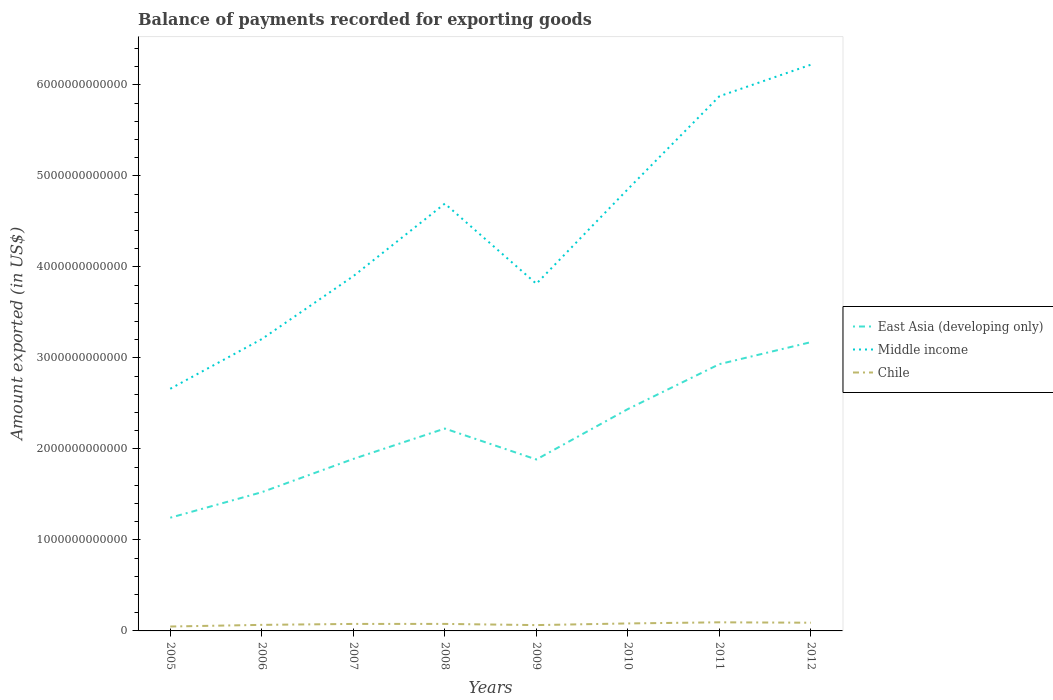How many different coloured lines are there?
Keep it short and to the point. 3. Does the line corresponding to Middle income intersect with the line corresponding to Chile?
Give a very brief answer. No. Is the number of lines equal to the number of legend labels?
Keep it short and to the point. Yes. Across all years, what is the maximum amount exported in East Asia (developing only)?
Give a very brief answer. 1.24e+12. In which year was the amount exported in Chile maximum?
Your answer should be compact. 2005. What is the total amount exported in Middle income in the graph?
Your answer should be very brief. -3.21e+12. What is the difference between the highest and the second highest amount exported in Chile?
Your answer should be very brief. 4.61e+1. What is the difference between two consecutive major ticks on the Y-axis?
Your answer should be very brief. 1.00e+12. Does the graph contain any zero values?
Offer a terse response. No. Where does the legend appear in the graph?
Offer a terse response. Center right. What is the title of the graph?
Provide a succinct answer. Balance of payments recorded for exporting goods. Does "Switzerland" appear as one of the legend labels in the graph?
Make the answer very short. No. What is the label or title of the Y-axis?
Provide a succinct answer. Amount exported (in US$). What is the Amount exported (in US$) in East Asia (developing only) in 2005?
Make the answer very short. 1.24e+12. What is the Amount exported (in US$) of Middle income in 2005?
Offer a terse response. 2.66e+12. What is the Amount exported (in US$) in Chile in 2005?
Your answer should be compact. 4.84e+1. What is the Amount exported (in US$) in East Asia (developing only) in 2006?
Your answer should be compact. 1.52e+12. What is the Amount exported (in US$) of Middle income in 2006?
Ensure brevity in your answer.  3.21e+12. What is the Amount exported (in US$) in Chile in 2006?
Your answer should be compact. 6.65e+1. What is the Amount exported (in US$) of East Asia (developing only) in 2007?
Keep it short and to the point. 1.89e+12. What is the Amount exported (in US$) in Middle income in 2007?
Make the answer very short. 3.90e+12. What is the Amount exported (in US$) of Chile in 2007?
Your answer should be very brief. 7.69e+1. What is the Amount exported (in US$) of East Asia (developing only) in 2008?
Your answer should be compact. 2.22e+12. What is the Amount exported (in US$) of Middle income in 2008?
Offer a very short reply. 4.70e+12. What is the Amount exported (in US$) in Chile in 2008?
Give a very brief answer. 7.71e+1. What is the Amount exported (in US$) in East Asia (developing only) in 2009?
Your response must be concise. 1.88e+12. What is the Amount exported (in US$) of Middle income in 2009?
Offer a terse response. 3.81e+12. What is the Amount exported (in US$) in Chile in 2009?
Make the answer very short. 6.40e+1. What is the Amount exported (in US$) of East Asia (developing only) in 2010?
Your answer should be compact. 2.44e+12. What is the Amount exported (in US$) of Middle income in 2010?
Ensure brevity in your answer.  4.85e+12. What is the Amount exported (in US$) in Chile in 2010?
Give a very brief answer. 8.23e+1. What is the Amount exported (in US$) in East Asia (developing only) in 2011?
Make the answer very short. 2.93e+12. What is the Amount exported (in US$) of Middle income in 2011?
Provide a succinct answer. 5.87e+12. What is the Amount exported (in US$) in Chile in 2011?
Offer a terse response. 9.45e+1. What is the Amount exported (in US$) in East Asia (developing only) in 2012?
Your response must be concise. 3.17e+12. What is the Amount exported (in US$) of Middle income in 2012?
Provide a succinct answer. 6.22e+12. What is the Amount exported (in US$) of Chile in 2012?
Your response must be concise. 9.02e+1. Across all years, what is the maximum Amount exported (in US$) in East Asia (developing only)?
Provide a succinct answer. 3.17e+12. Across all years, what is the maximum Amount exported (in US$) of Middle income?
Offer a very short reply. 6.22e+12. Across all years, what is the maximum Amount exported (in US$) of Chile?
Make the answer very short. 9.45e+1. Across all years, what is the minimum Amount exported (in US$) of East Asia (developing only)?
Your answer should be very brief. 1.24e+12. Across all years, what is the minimum Amount exported (in US$) in Middle income?
Your answer should be very brief. 2.66e+12. Across all years, what is the minimum Amount exported (in US$) of Chile?
Provide a short and direct response. 4.84e+1. What is the total Amount exported (in US$) of East Asia (developing only) in the graph?
Offer a very short reply. 1.73e+13. What is the total Amount exported (in US$) in Middle income in the graph?
Provide a short and direct response. 3.52e+13. What is the total Amount exported (in US$) in Chile in the graph?
Your answer should be very brief. 6.00e+11. What is the difference between the Amount exported (in US$) in East Asia (developing only) in 2005 and that in 2006?
Keep it short and to the point. -2.80e+11. What is the difference between the Amount exported (in US$) in Middle income in 2005 and that in 2006?
Provide a short and direct response. -5.46e+11. What is the difference between the Amount exported (in US$) in Chile in 2005 and that in 2006?
Keep it short and to the point. -1.81e+1. What is the difference between the Amount exported (in US$) in East Asia (developing only) in 2005 and that in 2007?
Your answer should be compact. -6.46e+11. What is the difference between the Amount exported (in US$) of Middle income in 2005 and that in 2007?
Provide a short and direct response. -1.24e+12. What is the difference between the Amount exported (in US$) in Chile in 2005 and that in 2007?
Provide a succinct answer. -2.85e+1. What is the difference between the Amount exported (in US$) of East Asia (developing only) in 2005 and that in 2008?
Your answer should be compact. -9.80e+11. What is the difference between the Amount exported (in US$) of Middle income in 2005 and that in 2008?
Ensure brevity in your answer.  -2.03e+12. What is the difference between the Amount exported (in US$) of Chile in 2005 and that in 2008?
Your answer should be compact. -2.87e+1. What is the difference between the Amount exported (in US$) of East Asia (developing only) in 2005 and that in 2009?
Keep it short and to the point. -6.40e+11. What is the difference between the Amount exported (in US$) of Middle income in 2005 and that in 2009?
Give a very brief answer. -1.15e+12. What is the difference between the Amount exported (in US$) of Chile in 2005 and that in 2009?
Ensure brevity in your answer.  -1.56e+1. What is the difference between the Amount exported (in US$) of East Asia (developing only) in 2005 and that in 2010?
Your response must be concise. -1.19e+12. What is the difference between the Amount exported (in US$) of Middle income in 2005 and that in 2010?
Your answer should be very brief. -2.19e+12. What is the difference between the Amount exported (in US$) of Chile in 2005 and that in 2010?
Your response must be concise. -3.39e+1. What is the difference between the Amount exported (in US$) in East Asia (developing only) in 2005 and that in 2011?
Provide a short and direct response. -1.69e+12. What is the difference between the Amount exported (in US$) in Middle income in 2005 and that in 2011?
Provide a succinct answer. -3.21e+12. What is the difference between the Amount exported (in US$) in Chile in 2005 and that in 2011?
Ensure brevity in your answer.  -4.61e+1. What is the difference between the Amount exported (in US$) of East Asia (developing only) in 2005 and that in 2012?
Keep it short and to the point. -1.93e+12. What is the difference between the Amount exported (in US$) of Middle income in 2005 and that in 2012?
Offer a very short reply. -3.56e+12. What is the difference between the Amount exported (in US$) in Chile in 2005 and that in 2012?
Your answer should be very brief. -4.18e+1. What is the difference between the Amount exported (in US$) in East Asia (developing only) in 2006 and that in 2007?
Ensure brevity in your answer.  -3.66e+11. What is the difference between the Amount exported (in US$) of Middle income in 2006 and that in 2007?
Provide a short and direct response. -6.91e+11. What is the difference between the Amount exported (in US$) in Chile in 2006 and that in 2007?
Your answer should be very brief. -1.04e+1. What is the difference between the Amount exported (in US$) of East Asia (developing only) in 2006 and that in 2008?
Make the answer very short. -6.99e+11. What is the difference between the Amount exported (in US$) of Middle income in 2006 and that in 2008?
Give a very brief answer. -1.49e+12. What is the difference between the Amount exported (in US$) in Chile in 2006 and that in 2008?
Give a very brief answer. -1.06e+1. What is the difference between the Amount exported (in US$) in East Asia (developing only) in 2006 and that in 2009?
Ensure brevity in your answer.  -3.59e+11. What is the difference between the Amount exported (in US$) of Middle income in 2006 and that in 2009?
Your response must be concise. -6.08e+11. What is the difference between the Amount exported (in US$) of Chile in 2006 and that in 2009?
Keep it short and to the point. 2.56e+09. What is the difference between the Amount exported (in US$) in East Asia (developing only) in 2006 and that in 2010?
Your answer should be very brief. -9.13e+11. What is the difference between the Amount exported (in US$) in Middle income in 2006 and that in 2010?
Provide a short and direct response. -1.65e+12. What is the difference between the Amount exported (in US$) in Chile in 2006 and that in 2010?
Your answer should be very brief. -1.57e+1. What is the difference between the Amount exported (in US$) of East Asia (developing only) in 2006 and that in 2011?
Give a very brief answer. -1.41e+12. What is the difference between the Amount exported (in US$) in Middle income in 2006 and that in 2011?
Offer a terse response. -2.67e+12. What is the difference between the Amount exported (in US$) in Chile in 2006 and that in 2011?
Your answer should be compact. -2.80e+1. What is the difference between the Amount exported (in US$) of East Asia (developing only) in 2006 and that in 2012?
Provide a short and direct response. -1.65e+12. What is the difference between the Amount exported (in US$) in Middle income in 2006 and that in 2012?
Your answer should be very brief. -3.02e+12. What is the difference between the Amount exported (in US$) of Chile in 2006 and that in 2012?
Make the answer very short. -2.37e+1. What is the difference between the Amount exported (in US$) of East Asia (developing only) in 2007 and that in 2008?
Ensure brevity in your answer.  -3.34e+11. What is the difference between the Amount exported (in US$) of Middle income in 2007 and that in 2008?
Offer a terse response. -7.97e+11. What is the difference between the Amount exported (in US$) in Chile in 2007 and that in 2008?
Ensure brevity in your answer.  -1.48e+08. What is the difference between the Amount exported (in US$) in East Asia (developing only) in 2007 and that in 2009?
Keep it short and to the point. 6.33e+09. What is the difference between the Amount exported (in US$) of Middle income in 2007 and that in 2009?
Your response must be concise. 8.34e+1. What is the difference between the Amount exported (in US$) of Chile in 2007 and that in 2009?
Offer a terse response. 1.30e+1. What is the difference between the Amount exported (in US$) in East Asia (developing only) in 2007 and that in 2010?
Make the answer very short. -5.48e+11. What is the difference between the Amount exported (in US$) of Middle income in 2007 and that in 2010?
Keep it short and to the point. -9.56e+11. What is the difference between the Amount exported (in US$) of Chile in 2007 and that in 2010?
Your answer should be compact. -5.32e+09. What is the difference between the Amount exported (in US$) of East Asia (developing only) in 2007 and that in 2011?
Provide a succinct answer. -1.04e+12. What is the difference between the Amount exported (in US$) in Middle income in 2007 and that in 2011?
Provide a succinct answer. -1.98e+12. What is the difference between the Amount exported (in US$) of Chile in 2007 and that in 2011?
Keep it short and to the point. -1.76e+1. What is the difference between the Amount exported (in US$) in East Asia (developing only) in 2007 and that in 2012?
Provide a succinct answer. -1.28e+12. What is the difference between the Amount exported (in US$) of Middle income in 2007 and that in 2012?
Your response must be concise. -2.32e+12. What is the difference between the Amount exported (in US$) of Chile in 2007 and that in 2012?
Offer a very short reply. -1.32e+1. What is the difference between the Amount exported (in US$) of East Asia (developing only) in 2008 and that in 2009?
Provide a short and direct response. 3.40e+11. What is the difference between the Amount exported (in US$) in Middle income in 2008 and that in 2009?
Keep it short and to the point. 8.81e+11. What is the difference between the Amount exported (in US$) of Chile in 2008 and that in 2009?
Provide a short and direct response. 1.31e+1. What is the difference between the Amount exported (in US$) of East Asia (developing only) in 2008 and that in 2010?
Give a very brief answer. -2.14e+11. What is the difference between the Amount exported (in US$) of Middle income in 2008 and that in 2010?
Give a very brief answer. -1.59e+11. What is the difference between the Amount exported (in US$) in Chile in 2008 and that in 2010?
Your response must be concise. -5.17e+09. What is the difference between the Amount exported (in US$) in East Asia (developing only) in 2008 and that in 2011?
Your response must be concise. -7.08e+11. What is the difference between the Amount exported (in US$) in Middle income in 2008 and that in 2011?
Keep it short and to the point. -1.18e+12. What is the difference between the Amount exported (in US$) in Chile in 2008 and that in 2011?
Offer a terse response. -1.75e+1. What is the difference between the Amount exported (in US$) of East Asia (developing only) in 2008 and that in 2012?
Ensure brevity in your answer.  -9.50e+11. What is the difference between the Amount exported (in US$) in Middle income in 2008 and that in 2012?
Offer a terse response. -1.53e+12. What is the difference between the Amount exported (in US$) in Chile in 2008 and that in 2012?
Provide a succinct answer. -1.31e+1. What is the difference between the Amount exported (in US$) in East Asia (developing only) in 2009 and that in 2010?
Provide a short and direct response. -5.54e+11. What is the difference between the Amount exported (in US$) of Middle income in 2009 and that in 2010?
Your response must be concise. -1.04e+12. What is the difference between the Amount exported (in US$) of Chile in 2009 and that in 2010?
Provide a succinct answer. -1.83e+1. What is the difference between the Amount exported (in US$) of East Asia (developing only) in 2009 and that in 2011?
Ensure brevity in your answer.  -1.05e+12. What is the difference between the Amount exported (in US$) of Middle income in 2009 and that in 2011?
Make the answer very short. -2.06e+12. What is the difference between the Amount exported (in US$) in Chile in 2009 and that in 2011?
Ensure brevity in your answer.  -3.06e+1. What is the difference between the Amount exported (in US$) in East Asia (developing only) in 2009 and that in 2012?
Provide a succinct answer. -1.29e+12. What is the difference between the Amount exported (in US$) in Middle income in 2009 and that in 2012?
Give a very brief answer. -2.41e+12. What is the difference between the Amount exported (in US$) in Chile in 2009 and that in 2012?
Your response must be concise. -2.62e+1. What is the difference between the Amount exported (in US$) of East Asia (developing only) in 2010 and that in 2011?
Give a very brief answer. -4.94e+11. What is the difference between the Amount exported (in US$) in Middle income in 2010 and that in 2011?
Offer a very short reply. -1.02e+12. What is the difference between the Amount exported (in US$) in Chile in 2010 and that in 2011?
Your response must be concise. -1.23e+1. What is the difference between the Amount exported (in US$) of East Asia (developing only) in 2010 and that in 2012?
Provide a short and direct response. -7.35e+11. What is the difference between the Amount exported (in US$) in Middle income in 2010 and that in 2012?
Give a very brief answer. -1.37e+12. What is the difference between the Amount exported (in US$) of Chile in 2010 and that in 2012?
Your response must be concise. -7.92e+09. What is the difference between the Amount exported (in US$) in East Asia (developing only) in 2011 and that in 2012?
Provide a short and direct response. -2.42e+11. What is the difference between the Amount exported (in US$) of Middle income in 2011 and that in 2012?
Provide a succinct answer. -3.47e+11. What is the difference between the Amount exported (in US$) of Chile in 2011 and that in 2012?
Offer a very short reply. 4.37e+09. What is the difference between the Amount exported (in US$) in East Asia (developing only) in 2005 and the Amount exported (in US$) in Middle income in 2006?
Your answer should be compact. -1.96e+12. What is the difference between the Amount exported (in US$) of East Asia (developing only) in 2005 and the Amount exported (in US$) of Chile in 2006?
Offer a terse response. 1.18e+12. What is the difference between the Amount exported (in US$) in Middle income in 2005 and the Amount exported (in US$) in Chile in 2006?
Provide a succinct answer. 2.59e+12. What is the difference between the Amount exported (in US$) in East Asia (developing only) in 2005 and the Amount exported (in US$) in Middle income in 2007?
Your answer should be compact. -2.65e+12. What is the difference between the Amount exported (in US$) of East Asia (developing only) in 2005 and the Amount exported (in US$) of Chile in 2007?
Offer a very short reply. 1.17e+12. What is the difference between the Amount exported (in US$) in Middle income in 2005 and the Amount exported (in US$) in Chile in 2007?
Ensure brevity in your answer.  2.58e+12. What is the difference between the Amount exported (in US$) of East Asia (developing only) in 2005 and the Amount exported (in US$) of Middle income in 2008?
Your answer should be very brief. -3.45e+12. What is the difference between the Amount exported (in US$) in East Asia (developing only) in 2005 and the Amount exported (in US$) in Chile in 2008?
Make the answer very short. 1.17e+12. What is the difference between the Amount exported (in US$) of Middle income in 2005 and the Amount exported (in US$) of Chile in 2008?
Offer a terse response. 2.58e+12. What is the difference between the Amount exported (in US$) in East Asia (developing only) in 2005 and the Amount exported (in US$) in Middle income in 2009?
Your answer should be compact. -2.57e+12. What is the difference between the Amount exported (in US$) in East Asia (developing only) in 2005 and the Amount exported (in US$) in Chile in 2009?
Offer a terse response. 1.18e+12. What is the difference between the Amount exported (in US$) of Middle income in 2005 and the Amount exported (in US$) of Chile in 2009?
Your answer should be very brief. 2.60e+12. What is the difference between the Amount exported (in US$) in East Asia (developing only) in 2005 and the Amount exported (in US$) in Middle income in 2010?
Ensure brevity in your answer.  -3.61e+12. What is the difference between the Amount exported (in US$) in East Asia (developing only) in 2005 and the Amount exported (in US$) in Chile in 2010?
Make the answer very short. 1.16e+12. What is the difference between the Amount exported (in US$) in Middle income in 2005 and the Amount exported (in US$) in Chile in 2010?
Offer a terse response. 2.58e+12. What is the difference between the Amount exported (in US$) of East Asia (developing only) in 2005 and the Amount exported (in US$) of Middle income in 2011?
Your answer should be compact. -4.63e+12. What is the difference between the Amount exported (in US$) of East Asia (developing only) in 2005 and the Amount exported (in US$) of Chile in 2011?
Give a very brief answer. 1.15e+12. What is the difference between the Amount exported (in US$) in Middle income in 2005 and the Amount exported (in US$) in Chile in 2011?
Give a very brief answer. 2.57e+12. What is the difference between the Amount exported (in US$) in East Asia (developing only) in 2005 and the Amount exported (in US$) in Middle income in 2012?
Provide a succinct answer. -4.98e+12. What is the difference between the Amount exported (in US$) of East Asia (developing only) in 2005 and the Amount exported (in US$) of Chile in 2012?
Keep it short and to the point. 1.15e+12. What is the difference between the Amount exported (in US$) in Middle income in 2005 and the Amount exported (in US$) in Chile in 2012?
Make the answer very short. 2.57e+12. What is the difference between the Amount exported (in US$) in East Asia (developing only) in 2006 and the Amount exported (in US$) in Middle income in 2007?
Your answer should be compact. -2.37e+12. What is the difference between the Amount exported (in US$) of East Asia (developing only) in 2006 and the Amount exported (in US$) of Chile in 2007?
Your response must be concise. 1.45e+12. What is the difference between the Amount exported (in US$) of Middle income in 2006 and the Amount exported (in US$) of Chile in 2007?
Keep it short and to the point. 3.13e+12. What is the difference between the Amount exported (in US$) in East Asia (developing only) in 2006 and the Amount exported (in US$) in Middle income in 2008?
Provide a short and direct response. -3.17e+12. What is the difference between the Amount exported (in US$) in East Asia (developing only) in 2006 and the Amount exported (in US$) in Chile in 2008?
Offer a very short reply. 1.45e+12. What is the difference between the Amount exported (in US$) of Middle income in 2006 and the Amount exported (in US$) of Chile in 2008?
Give a very brief answer. 3.13e+12. What is the difference between the Amount exported (in US$) in East Asia (developing only) in 2006 and the Amount exported (in US$) in Middle income in 2009?
Make the answer very short. -2.29e+12. What is the difference between the Amount exported (in US$) in East Asia (developing only) in 2006 and the Amount exported (in US$) in Chile in 2009?
Your answer should be very brief. 1.46e+12. What is the difference between the Amount exported (in US$) in Middle income in 2006 and the Amount exported (in US$) in Chile in 2009?
Your answer should be compact. 3.14e+12. What is the difference between the Amount exported (in US$) in East Asia (developing only) in 2006 and the Amount exported (in US$) in Middle income in 2010?
Give a very brief answer. -3.33e+12. What is the difference between the Amount exported (in US$) of East Asia (developing only) in 2006 and the Amount exported (in US$) of Chile in 2010?
Your response must be concise. 1.44e+12. What is the difference between the Amount exported (in US$) of Middle income in 2006 and the Amount exported (in US$) of Chile in 2010?
Your response must be concise. 3.12e+12. What is the difference between the Amount exported (in US$) of East Asia (developing only) in 2006 and the Amount exported (in US$) of Middle income in 2011?
Keep it short and to the point. -4.35e+12. What is the difference between the Amount exported (in US$) of East Asia (developing only) in 2006 and the Amount exported (in US$) of Chile in 2011?
Make the answer very short. 1.43e+12. What is the difference between the Amount exported (in US$) of Middle income in 2006 and the Amount exported (in US$) of Chile in 2011?
Make the answer very short. 3.11e+12. What is the difference between the Amount exported (in US$) of East Asia (developing only) in 2006 and the Amount exported (in US$) of Middle income in 2012?
Ensure brevity in your answer.  -4.70e+12. What is the difference between the Amount exported (in US$) in East Asia (developing only) in 2006 and the Amount exported (in US$) in Chile in 2012?
Make the answer very short. 1.43e+12. What is the difference between the Amount exported (in US$) of Middle income in 2006 and the Amount exported (in US$) of Chile in 2012?
Your response must be concise. 3.12e+12. What is the difference between the Amount exported (in US$) of East Asia (developing only) in 2007 and the Amount exported (in US$) of Middle income in 2008?
Give a very brief answer. -2.81e+12. What is the difference between the Amount exported (in US$) of East Asia (developing only) in 2007 and the Amount exported (in US$) of Chile in 2008?
Offer a very short reply. 1.81e+12. What is the difference between the Amount exported (in US$) of Middle income in 2007 and the Amount exported (in US$) of Chile in 2008?
Ensure brevity in your answer.  3.82e+12. What is the difference between the Amount exported (in US$) of East Asia (developing only) in 2007 and the Amount exported (in US$) of Middle income in 2009?
Your response must be concise. -1.92e+12. What is the difference between the Amount exported (in US$) in East Asia (developing only) in 2007 and the Amount exported (in US$) in Chile in 2009?
Give a very brief answer. 1.83e+12. What is the difference between the Amount exported (in US$) in Middle income in 2007 and the Amount exported (in US$) in Chile in 2009?
Keep it short and to the point. 3.83e+12. What is the difference between the Amount exported (in US$) of East Asia (developing only) in 2007 and the Amount exported (in US$) of Middle income in 2010?
Keep it short and to the point. -2.96e+12. What is the difference between the Amount exported (in US$) of East Asia (developing only) in 2007 and the Amount exported (in US$) of Chile in 2010?
Your answer should be very brief. 1.81e+12. What is the difference between the Amount exported (in US$) of Middle income in 2007 and the Amount exported (in US$) of Chile in 2010?
Your response must be concise. 3.82e+12. What is the difference between the Amount exported (in US$) in East Asia (developing only) in 2007 and the Amount exported (in US$) in Middle income in 2011?
Your answer should be very brief. -3.99e+12. What is the difference between the Amount exported (in US$) of East Asia (developing only) in 2007 and the Amount exported (in US$) of Chile in 2011?
Your answer should be compact. 1.80e+12. What is the difference between the Amount exported (in US$) in Middle income in 2007 and the Amount exported (in US$) in Chile in 2011?
Ensure brevity in your answer.  3.80e+12. What is the difference between the Amount exported (in US$) in East Asia (developing only) in 2007 and the Amount exported (in US$) in Middle income in 2012?
Your response must be concise. -4.33e+12. What is the difference between the Amount exported (in US$) of East Asia (developing only) in 2007 and the Amount exported (in US$) of Chile in 2012?
Your answer should be very brief. 1.80e+12. What is the difference between the Amount exported (in US$) in Middle income in 2007 and the Amount exported (in US$) in Chile in 2012?
Offer a very short reply. 3.81e+12. What is the difference between the Amount exported (in US$) of East Asia (developing only) in 2008 and the Amount exported (in US$) of Middle income in 2009?
Your answer should be compact. -1.59e+12. What is the difference between the Amount exported (in US$) in East Asia (developing only) in 2008 and the Amount exported (in US$) in Chile in 2009?
Offer a terse response. 2.16e+12. What is the difference between the Amount exported (in US$) in Middle income in 2008 and the Amount exported (in US$) in Chile in 2009?
Provide a short and direct response. 4.63e+12. What is the difference between the Amount exported (in US$) in East Asia (developing only) in 2008 and the Amount exported (in US$) in Middle income in 2010?
Provide a succinct answer. -2.63e+12. What is the difference between the Amount exported (in US$) in East Asia (developing only) in 2008 and the Amount exported (in US$) in Chile in 2010?
Your answer should be very brief. 2.14e+12. What is the difference between the Amount exported (in US$) in Middle income in 2008 and the Amount exported (in US$) in Chile in 2010?
Offer a terse response. 4.61e+12. What is the difference between the Amount exported (in US$) in East Asia (developing only) in 2008 and the Amount exported (in US$) in Middle income in 2011?
Ensure brevity in your answer.  -3.65e+12. What is the difference between the Amount exported (in US$) of East Asia (developing only) in 2008 and the Amount exported (in US$) of Chile in 2011?
Make the answer very short. 2.13e+12. What is the difference between the Amount exported (in US$) in Middle income in 2008 and the Amount exported (in US$) in Chile in 2011?
Ensure brevity in your answer.  4.60e+12. What is the difference between the Amount exported (in US$) of East Asia (developing only) in 2008 and the Amount exported (in US$) of Middle income in 2012?
Make the answer very short. -4.00e+12. What is the difference between the Amount exported (in US$) in East Asia (developing only) in 2008 and the Amount exported (in US$) in Chile in 2012?
Provide a succinct answer. 2.13e+12. What is the difference between the Amount exported (in US$) in Middle income in 2008 and the Amount exported (in US$) in Chile in 2012?
Your answer should be very brief. 4.60e+12. What is the difference between the Amount exported (in US$) in East Asia (developing only) in 2009 and the Amount exported (in US$) in Middle income in 2010?
Offer a terse response. -2.97e+12. What is the difference between the Amount exported (in US$) of East Asia (developing only) in 2009 and the Amount exported (in US$) of Chile in 2010?
Give a very brief answer. 1.80e+12. What is the difference between the Amount exported (in US$) of Middle income in 2009 and the Amount exported (in US$) of Chile in 2010?
Your response must be concise. 3.73e+12. What is the difference between the Amount exported (in US$) in East Asia (developing only) in 2009 and the Amount exported (in US$) in Middle income in 2011?
Make the answer very short. -3.99e+12. What is the difference between the Amount exported (in US$) in East Asia (developing only) in 2009 and the Amount exported (in US$) in Chile in 2011?
Offer a very short reply. 1.79e+12. What is the difference between the Amount exported (in US$) in Middle income in 2009 and the Amount exported (in US$) in Chile in 2011?
Provide a succinct answer. 3.72e+12. What is the difference between the Amount exported (in US$) in East Asia (developing only) in 2009 and the Amount exported (in US$) in Middle income in 2012?
Your answer should be very brief. -4.34e+12. What is the difference between the Amount exported (in US$) of East Asia (developing only) in 2009 and the Amount exported (in US$) of Chile in 2012?
Your answer should be very brief. 1.79e+12. What is the difference between the Amount exported (in US$) of Middle income in 2009 and the Amount exported (in US$) of Chile in 2012?
Ensure brevity in your answer.  3.72e+12. What is the difference between the Amount exported (in US$) in East Asia (developing only) in 2010 and the Amount exported (in US$) in Middle income in 2011?
Your answer should be very brief. -3.44e+12. What is the difference between the Amount exported (in US$) of East Asia (developing only) in 2010 and the Amount exported (in US$) of Chile in 2011?
Ensure brevity in your answer.  2.34e+12. What is the difference between the Amount exported (in US$) of Middle income in 2010 and the Amount exported (in US$) of Chile in 2011?
Your answer should be very brief. 4.76e+12. What is the difference between the Amount exported (in US$) in East Asia (developing only) in 2010 and the Amount exported (in US$) in Middle income in 2012?
Make the answer very short. -3.78e+12. What is the difference between the Amount exported (in US$) in East Asia (developing only) in 2010 and the Amount exported (in US$) in Chile in 2012?
Give a very brief answer. 2.35e+12. What is the difference between the Amount exported (in US$) in Middle income in 2010 and the Amount exported (in US$) in Chile in 2012?
Provide a succinct answer. 4.76e+12. What is the difference between the Amount exported (in US$) of East Asia (developing only) in 2011 and the Amount exported (in US$) of Middle income in 2012?
Keep it short and to the point. -3.29e+12. What is the difference between the Amount exported (in US$) in East Asia (developing only) in 2011 and the Amount exported (in US$) in Chile in 2012?
Your answer should be very brief. 2.84e+12. What is the difference between the Amount exported (in US$) in Middle income in 2011 and the Amount exported (in US$) in Chile in 2012?
Provide a succinct answer. 5.78e+12. What is the average Amount exported (in US$) in East Asia (developing only) per year?
Your answer should be very brief. 2.16e+12. What is the average Amount exported (in US$) in Middle income per year?
Provide a succinct answer. 4.40e+12. What is the average Amount exported (in US$) in Chile per year?
Ensure brevity in your answer.  7.50e+1. In the year 2005, what is the difference between the Amount exported (in US$) in East Asia (developing only) and Amount exported (in US$) in Middle income?
Provide a short and direct response. -1.42e+12. In the year 2005, what is the difference between the Amount exported (in US$) of East Asia (developing only) and Amount exported (in US$) of Chile?
Your answer should be compact. 1.20e+12. In the year 2005, what is the difference between the Amount exported (in US$) of Middle income and Amount exported (in US$) of Chile?
Provide a short and direct response. 2.61e+12. In the year 2006, what is the difference between the Amount exported (in US$) in East Asia (developing only) and Amount exported (in US$) in Middle income?
Your answer should be very brief. -1.68e+12. In the year 2006, what is the difference between the Amount exported (in US$) of East Asia (developing only) and Amount exported (in US$) of Chile?
Your response must be concise. 1.46e+12. In the year 2006, what is the difference between the Amount exported (in US$) of Middle income and Amount exported (in US$) of Chile?
Your response must be concise. 3.14e+12. In the year 2007, what is the difference between the Amount exported (in US$) in East Asia (developing only) and Amount exported (in US$) in Middle income?
Offer a very short reply. -2.01e+12. In the year 2007, what is the difference between the Amount exported (in US$) in East Asia (developing only) and Amount exported (in US$) in Chile?
Ensure brevity in your answer.  1.81e+12. In the year 2007, what is the difference between the Amount exported (in US$) in Middle income and Amount exported (in US$) in Chile?
Provide a short and direct response. 3.82e+12. In the year 2008, what is the difference between the Amount exported (in US$) in East Asia (developing only) and Amount exported (in US$) in Middle income?
Your response must be concise. -2.47e+12. In the year 2008, what is the difference between the Amount exported (in US$) in East Asia (developing only) and Amount exported (in US$) in Chile?
Provide a short and direct response. 2.15e+12. In the year 2008, what is the difference between the Amount exported (in US$) of Middle income and Amount exported (in US$) of Chile?
Your answer should be compact. 4.62e+12. In the year 2009, what is the difference between the Amount exported (in US$) of East Asia (developing only) and Amount exported (in US$) of Middle income?
Provide a succinct answer. -1.93e+12. In the year 2009, what is the difference between the Amount exported (in US$) of East Asia (developing only) and Amount exported (in US$) of Chile?
Your response must be concise. 1.82e+12. In the year 2009, what is the difference between the Amount exported (in US$) of Middle income and Amount exported (in US$) of Chile?
Keep it short and to the point. 3.75e+12. In the year 2010, what is the difference between the Amount exported (in US$) in East Asia (developing only) and Amount exported (in US$) in Middle income?
Your answer should be compact. -2.42e+12. In the year 2010, what is the difference between the Amount exported (in US$) in East Asia (developing only) and Amount exported (in US$) in Chile?
Your answer should be compact. 2.36e+12. In the year 2010, what is the difference between the Amount exported (in US$) in Middle income and Amount exported (in US$) in Chile?
Provide a short and direct response. 4.77e+12. In the year 2011, what is the difference between the Amount exported (in US$) in East Asia (developing only) and Amount exported (in US$) in Middle income?
Provide a succinct answer. -2.94e+12. In the year 2011, what is the difference between the Amount exported (in US$) of East Asia (developing only) and Amount exported (in US$) of Chile?
Your answer should be very brief. 2.84e+12. In the year 2011, what is the difference between the Amount exported (in US$) of Middle income and Amount exported (in US$) of Chile?
Ensure brevity in your answer.  5.78e+12. In the year 2012, what is the difference between the Amount exported (in US$) in East Asia (developing only) and Amount exported (in US$) in Middle income?
Make the answer very short. -3.05e+12. In the year 2012, what is the difference between the Amount exported (in US$) of East Asia (developing only) and Amount exported (in US$) of Chile?
Ensure brevity in your answer.  3.08e+12. In the year 2012, what is the difference between the Amount exported (in US$) in Middle income and Amount exported (in US$) in Chile?
Keep it short and to the point. 6.13e+12. What is the ratio of the Amount exported (in US$) of East Asia (developing only) in 2005 to that in 2006?
Offer a very short reply. 0.82. What is the ratio of the Amount exported (in US$) in Middle income in 2005 to that in 2006?
Give a very brief answer. 0.83. What is the ratio of the Amount exported (in US$) in Chile in 2005 to that in 2006?
Offer a very short reply. 0.73. What is the ratio of the Amount exported (in US$) of East Asia (developing only) in 2005 to that in 2007?
Your answer should be very brief. 0.66. What is the ratio of the Amount exported (in US$) in Middle income in 2005 to that in 2007?
Give a very brief answer. 0.68. What is the ratio of the Amount exported (in US$) in Chile in 2005 to that in 2007?
Make the answer very short. 0.63. What is the ratio of the Amount exported (in US$) in East Asia (developing only) in 2005 to that in 2008?
Make the answer very short. 0.56. What is the ratio of the Amount exported (in US$) in Middle income in 2005 to that in 2008?
Your response must be concise. 0.57. What is the ratio of the Amount exported (in US$) of Chile in 2005 to that in 2008?
Make the answer very short. 0.63. What is the ratio of the Amount exported (in US$) in East Asia (developing only) in 2005 to that in 2009?
Make the answer very short. 0.66. What is the ratio of the Amount exported (in US$) in Middle income in 2005 to that in 2009?
Offer a very short reply. 0.7. What is the ratio of the Amount exported (in US$) in Chile in 2005 to that in 2009?
Keep it short and to the point. 0.76. What is the ratio of the Amount exported (in US$) in East Asia (developing only) in 2005 to that in 2010?
Provide a short and direct response. 0.51. What is the ratio of the Amount exported (in US$) in Middle income in 2005 to that in 2010?
Your answer should be very brief. 0.55. What is the ratio of the Amount exported (in US$) in Chile in 2005 to that in 2010?
Provide a succinct answer. 0.59. What is the ratio of the Amount exported (in US$) of East Asia (developing only) in 2005 to that in 2011?
Keep it short and to the point. 0.42. What is the ratio of the Amount exported (in US$) in Middle income in 2005 to that in 2011?
Your answer should be compact. 0.45. What is the ratio of the Amount exported (in US$) of Chile in 2005 to that in 2011?
Your answer should be compact. 0.51. What is the ratio of the Amount exported (in US$) of East Asia (developing only) in 2005 to that in 2012?
Your answer should be very brief. 0.39. What is the ratio of the Amount exported (in US$) of Middle income in 2005 to that in 2012?
Keep it short and to the point. 0.43. What is the ratio of the Amount exported (in US$) of Chile in 2005 to that in 2012?
Give a very brief answer. 0.54. What is the ratio of the Amount exported (in US$) in East Asia (developing only) in 2006 to that in 2007?
Your answer should be compact. 0.81. What is the ratio of the Amount exported (in US$) in Middle income in 2006 to that in 2007?
Keep it short and to the point. 0.82. What is the ratio of the Amount exported (in US$) of Chile in 2006 to that in 2007?
Ensure brevity in your answer.  0.86. What is the ratio of the Amount exported (in US$) in East Asia (developing only) in 2006 to that in 2008?
Your answer should be very brief. 0.69. What is the ratio of the Amount exported (in US$) in Middle income in 2006 to that in 2008?
Your response must be concise. 0.68. What is the ratio of the Amount exported (in US$) in Chile in 2006 to that in 2008?
Provide a succinct answer. 0.86. What is the ratio of the Amount exported (in US$) of East Asia (developing only) in 2006 to that in 2009?
Offer a terse response. 0.81. What is the ratio of the Amount exported (in US$) in Middle income in 2006 to that in 2009?
Give a very brief answer. 0.84. What is the ratio of the Amount exported (in US$) of Chile in 2006 to that in 2009?
Provide a short and direct response. 1.04. What is the ratio of the Amount exported (in US$) in East Asia (developing only) in 2006 to that in 2010?
Make the answer very short. 0.63. What is the ratio of the Amount exported (in US$) in Middle income in 2006 to that in 2010?
Provide a short and direct response. 0.66. What is the ratio of the Amount exported (in US$) in Chile in 2006 to that in 2010?
Keep it short and to the point. 0.81. What is the ratio of the Amount exported (in US$) of East Asia (developing only) in 2006 to that in 2011?
Ensure brevity in your answer.  0.52. What is the ratio of the Amount exported (in US$) in Middle income in 2006 to that in 2011?
Your response must be concise. 0.55. What is the ratio of the Amount exported (in US$) in Chile in 2006 to that in 2011?
Offer a very short reply. 0.7. What is the ratio of the Amount exported (in US$) of East Asia (developing only) in 2006 to that in 2012?
Keep it short and to the point. 0.48. What is the ratio of the Amount exported (in US$) in Middle income in 2006 to that in 2012?
Ensure brevity in your answer.  0.52. What is the ratio of the Amount exported (in US$) of Chile in 2006 to that in 2012?
Provide a short and direct response. 0.74. What is the ratio of the Amount exported (in US$) in Middle income in 2007 to that in 2008?
Keep it short and to the point. 0.83. What is the ratio of the Amount exported (in US$) of Chile in 2007 to that in 2008?
Provide a succinct answer. 1. What is the ratio of the Amount exported (in US$) in East Asia (developing only) in 2007 to that in 2009?
Offer a very short reply. 1. What is the ratio of the Amount exported (in US$) in Middle income in 2007 to that in 2009?
Ensure brevity in your answer.  1.02. What is the ratio of the Amount exported (in US$) of Chile in 2007 to that in 2009?
Your answer should be compact. 1.2. What is the ratio of the Amount exported (in US$) in East Asia (developing only) in 2007 to that in 2010?
Provide a succinct answer. 0.78. What is the ratio of the Amount exported (in US$) in Middle income in 2007 to that in 2010?
Provide a short and direct response. 0.8. What is the ratio of the Amount exported (in US$) in Chile in 2007 to that in 2010?
Offer a very short reply. 0.94. What is the ratio of the Amount exported (in US$) in East Asia (developing only) in 2007 to that in 2011?
Keep it short and to the point. 0.64. What is the ratio of the Amount exported (in US$) in Middle income in 2007 to that in 2011?
Offer a very short reply. 0.66. What is the ratio of the Amount exported (in US$) in Chile in 2007 to that in 2011?
Ensure brevity in your answer.  0.81. What is the ratio of the Amount exported (in US$) in East Asia (developing only) in 2007 to that in 2012?
Give a very brief answer. 0.6. What is the ratio of the Amount exported (in US$) of Middle income in 2007 to that in 2012?
Keep it short and to the point. 0.63. What is the ratio of the Amount exported (in US$) of Chile in 2007 to that in 2012?
Your answer should be compact. 0.85. What is the ratio of the Amount exported (in US$) of East Asia (developing only) in 2008 to that in 2009?
Ensure brevity in your answer.  1.18. What is the ratio of the Amount exported (in US$) of Middle income in 2008 to that in 2009?
Offer a very short reply. 1.23. What is the ratio of the Amount exported (in US$) of Chile in 2008 to that in 2009?
Offer a very short reply. 1.21. What is the ratio of the Amount exported (in US$) in East Asia (developing only) in 2008 to that in 2010?
Your response must be concise. 0.91. What is the ratio of the Amount exported (in US$) in Middle income in 2008 to that in 2010?
Make the answer very short. 0.97. What is the ratio of the Amount exported (in US$) of Chile in 2008 to that in 2010?
Give a very brief answer. 0.94. What is the ratio of the Amount exported (in US$) of East Asia (developing only) in 2008 to that in 2011?
Your answer should be very brief. 0.76. What is the ratio of the Amount exported (in US$) in Middle income in 2008 to that in 2011?
Your answer should be very brief. 0.8. What is the ratio of the Amount exported (in US$) of Chile in 2008 to that in 2011?
Offer a very short reply. 0.82. What is the ratio of the Amount exported (in US$) of East Asia (developing only) in 2008 to that in 2012?
Ensure brevity in your answer.  0.7. What is the ratio of the Amount exported (in US$) of Middle income in 2008 to that in 2012?
Your answer should be very brief. 0.75. What is the ratio of the Amount exported (in US$) of Chile in 2008 to that in 2012?
Offer a very short reply. 0.85. What is the ratio of the Amount exported (in US$) of East Asia (developing only) in 2009 to that in 2010?
Your answer should be very brief. 0.77. What is the ratio of the Amount exported (in US$) in Middle income in 2009 to that in 2010?
Keep it short and to the point. 0.79. What is the ratio of the Amount exported (in US$) in Chile in 2009 to that in 2010?
Your answer should be compact. 0.78. What is the ratio of the Amount exported (in US$) in East Asia (developing only) in 2009 to that in 2011?
Keep it short and to the point. 0.64. What is the ratio of the Amount exported (in US$) of Middle income in 2009 to that in 2011?
Offer a very short reply. 0.65. What is the ratio of the Amount exported (in US$) in Chile in 2009 to that in 2011?
Your response must be concise. 0.68. What is the ratio of the Amount exported (in US$) of East Asia (developing only) in 2009 to that in 2012?
Keep it short and to the point. 0.59. What is the ratio of the Amount exported (in US$) of Middle income in 2009 to that in 2012?
Give a very brief answer. 0.61. What is the ratio of the Amount exported (in US$) in Chile in 2009 to that in 2012?
Provide a short and direct response. 0.71. What is the ratio of the Amount exported (in US$) in East Asia (developing only) in 2010 to that in 2011?
Offer a very short reply. 0.83. What is the ratio of the Amount exported (in US$) in Middle income in 2010 to that in 2011?
Make the answer very short. 0.83. What is the ratio of the Amount exported (in US$) of Chile in 2010 to that in 2011?
Your answer should be very brief. 0.87. What is the ratio of the Amount exported (in US$) in East Asia (developing only) in 2010 to that in 2012?
Ensure brevity in your answer.  0.77. What is the ratio of the Amount exported (in US$) in Middle income in 2010 to that in 2012?
Your answer should be very brief. 0.78. What is the ratio of the Amount exported (in US$) of Chile in 2010 to that in 2012?
Give a very brief answer. 0.91. What is the ratio of the Amount exported (in US$) in East Asia (developing only) in 2011 to that in 2012?
Provide a short and direct response. 0.92. What is the ratio of the Amount exported (in US$) in Middle income in 2011 to that in 2012?
Offer a very short reply. 0.94. What is the ratio of the Amount exported (in US$) in Chile in 2011 to that in 2012?
Make the answer very short. 1.05. What is the difference between the highest and the second highest Amount exported (in US$) of East Asia (developing only)?
Provide a succinct answer. 2.42e+11. What is the difference between the highest and the second highest Amount exported (in US$) of Middle income?
Ensure brevity in your answer.  3.47e+11. What is the difference between the highest and the second highest Amount exported (in US$) in Chile?
Keep it short and to the point. 4.37e+09. What is the difference between the highest and the lowest Amount exported (in US$) of East Asia (developing only)?
Your response must be concise. 1.93e+12. What is the difference between the highest and the lowest Amount exported (in US$) of Middle income?
Offer a very short reply. 3.56e+12. What is the difference between the highest and the lowest Amount exported (in US$) of Chile?
Provide a short and direct response. 4.61e+1. 